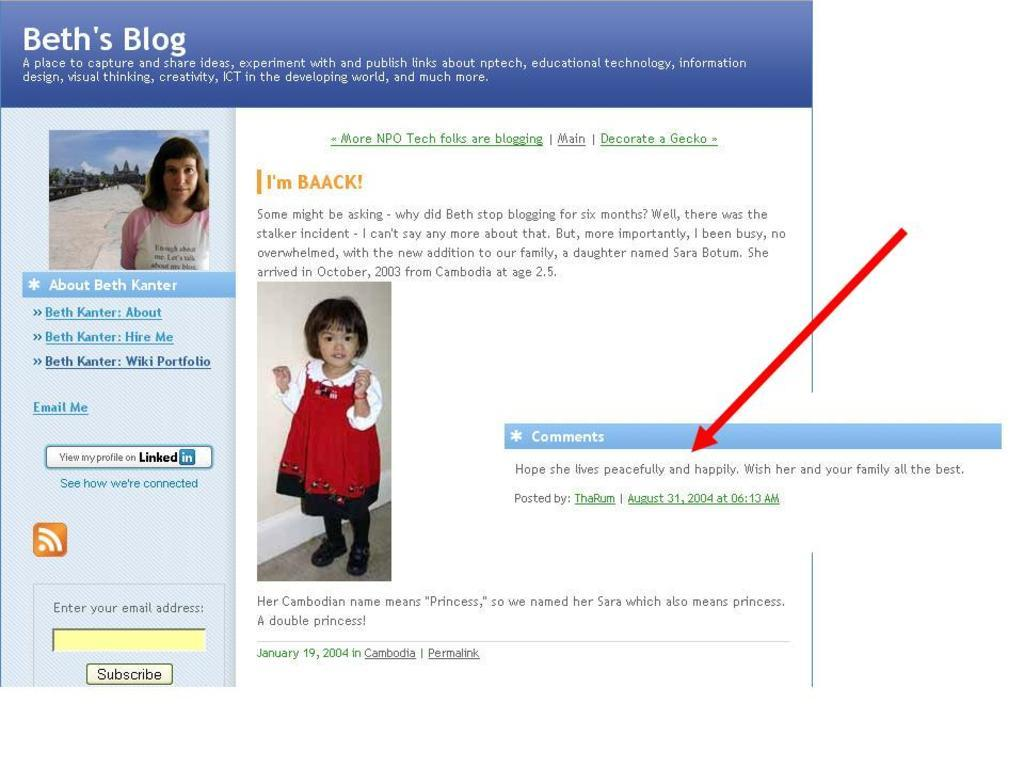What type of image is shown in the screenshot? The image is a screenshot of a screen. What can be seen in the screenshot of the screen? There are pictures of two persons in the screenshot. Is there any text present in the screenshot? Yes, there is text present in the screenshot. What type of crow can be seen sitting on a pile of coal in the screenshot? There is no crow or coal present in the screenshot; it only contains pictures of two persons and text. 